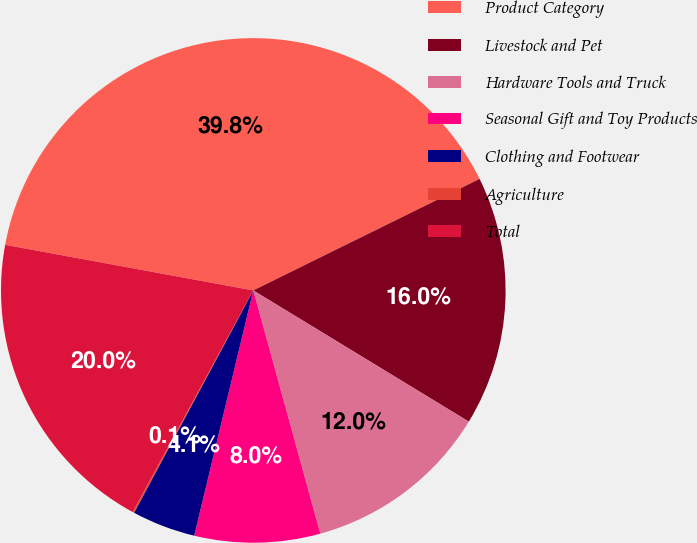Convert chart to OTSL. <chart><loc_0><loc_0><loc_500><loc_500><pie_chart><fcel>Product Category<fcel>Livestock and Pet<fcel>Hardware Tools and Truck<fcel>Seasonal Gift and Toy Products<fcel>Clothing and Footwear<fcel>Agriculture<fcel>Total<nl><fcel>39.82%<fcel>15.99%<fcel>12.02%<fcel>8.04%<fcel>4.07%<fcel>0.1%<fcel>19.96%<nl></chart> 